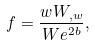Convert formula to latex. <formula><loc_0><loc_0><loc_500><loc_500>f = \frac { w W _ { , w } } { W e ^ { 2 b } } ,</formula> 